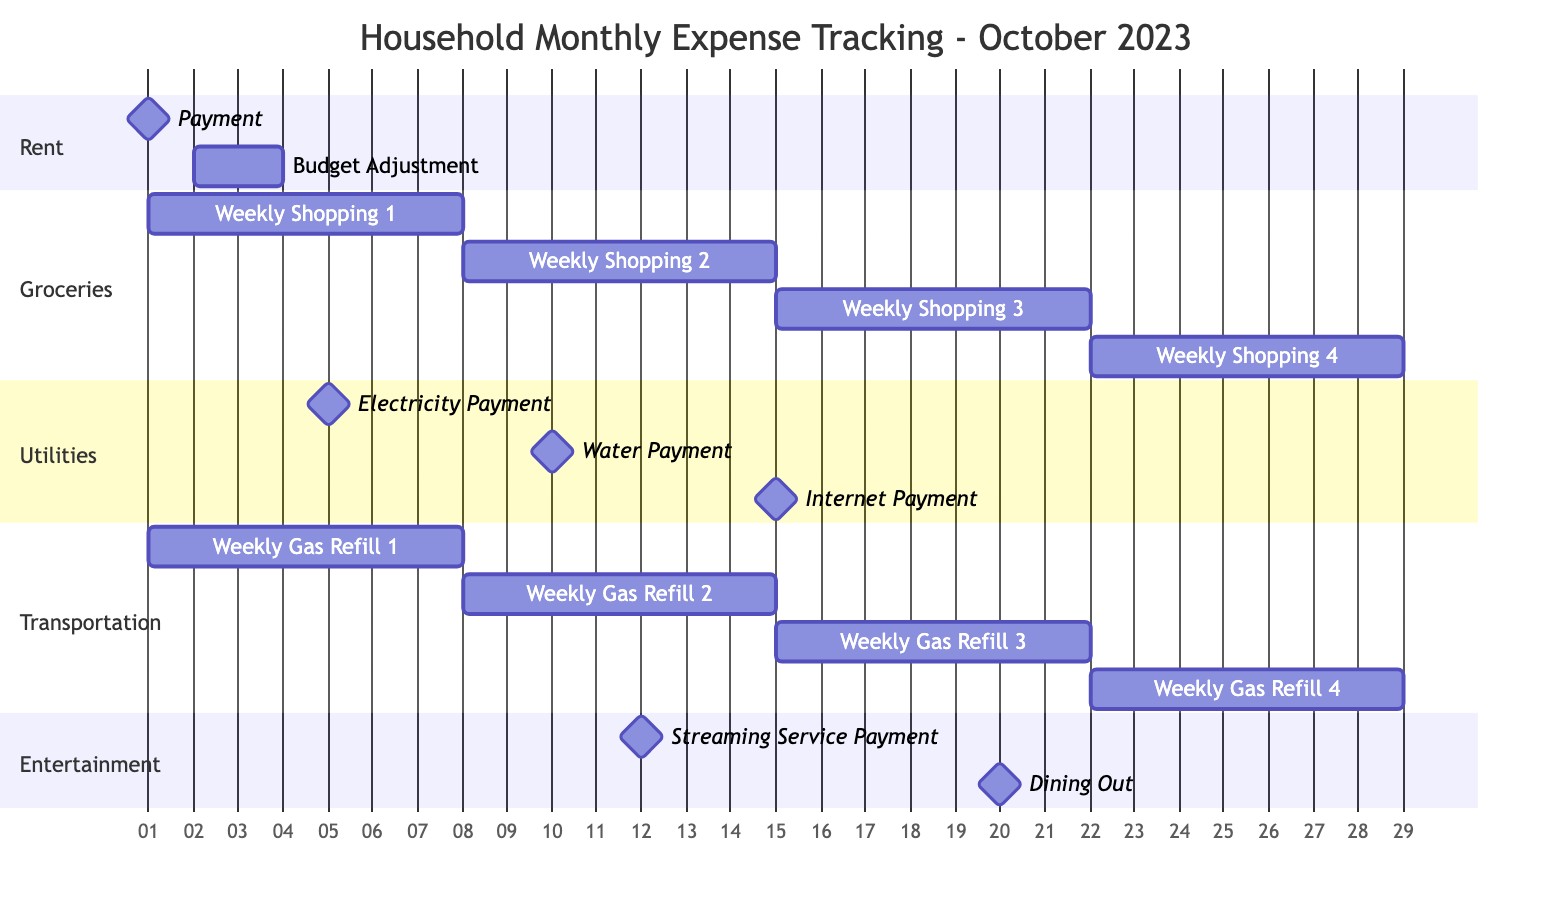What is the duration for the 'Weekly Shopping 2' phase? The 'Weekly Shopping 2' phase starts on October 8 and ends on October 14, which is a total of 7 days (one week duration).
Answer: 7 days How many categories are there in the diagram? The diagram contains five specific categories: Rent, Groceries, Utilities, Transportation, and Entertainment.
Answer: 5 How many payments are categorized under 'Utilities'? There are three distinct payments listed under 'Utilities': Electricity Payment, Water Payment, and Internet Payment.
Answer: 3 Which category has the first payment of the month? The first payment in the month is 'Payment' under the 'Rent' category on October 1.
Answer: Rent What are the exact dates for 'Weekly Gas Refill 3'? 'Weekly Gas Refill 3' starts on October 15 and ends on October 21.
Answer: October 15 - October 21 How many weeks does the 'Transportation' section cover? The 'Transportation' section includes four phases of 'Weekly Gas Refill', each spanning one week, thus covering a total of four weeks.
Answer: 4 weeks When is the last expense recorded in the month? The last expense recorded is 'Dining Out' on October 20; however, 'Weekly Shopping 4' includes activities that extend to October 28, despite not being categorized as an expense yet.
Answer: October 28 Which category contains the most phases? The 'Groceries' category has the most phases, containing four distinct weekly shopping sessions.
Answer: Groceries 